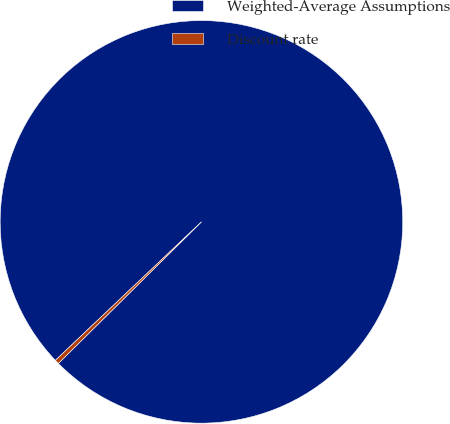<chart> <loc_0><loc_0><loc_500><loc_500><pie_chart><fcel>Weighted-Average Assumptions<fcel>Discount rate<nl><fcel>99.66%<fcel>0.34%<nl></chart> 